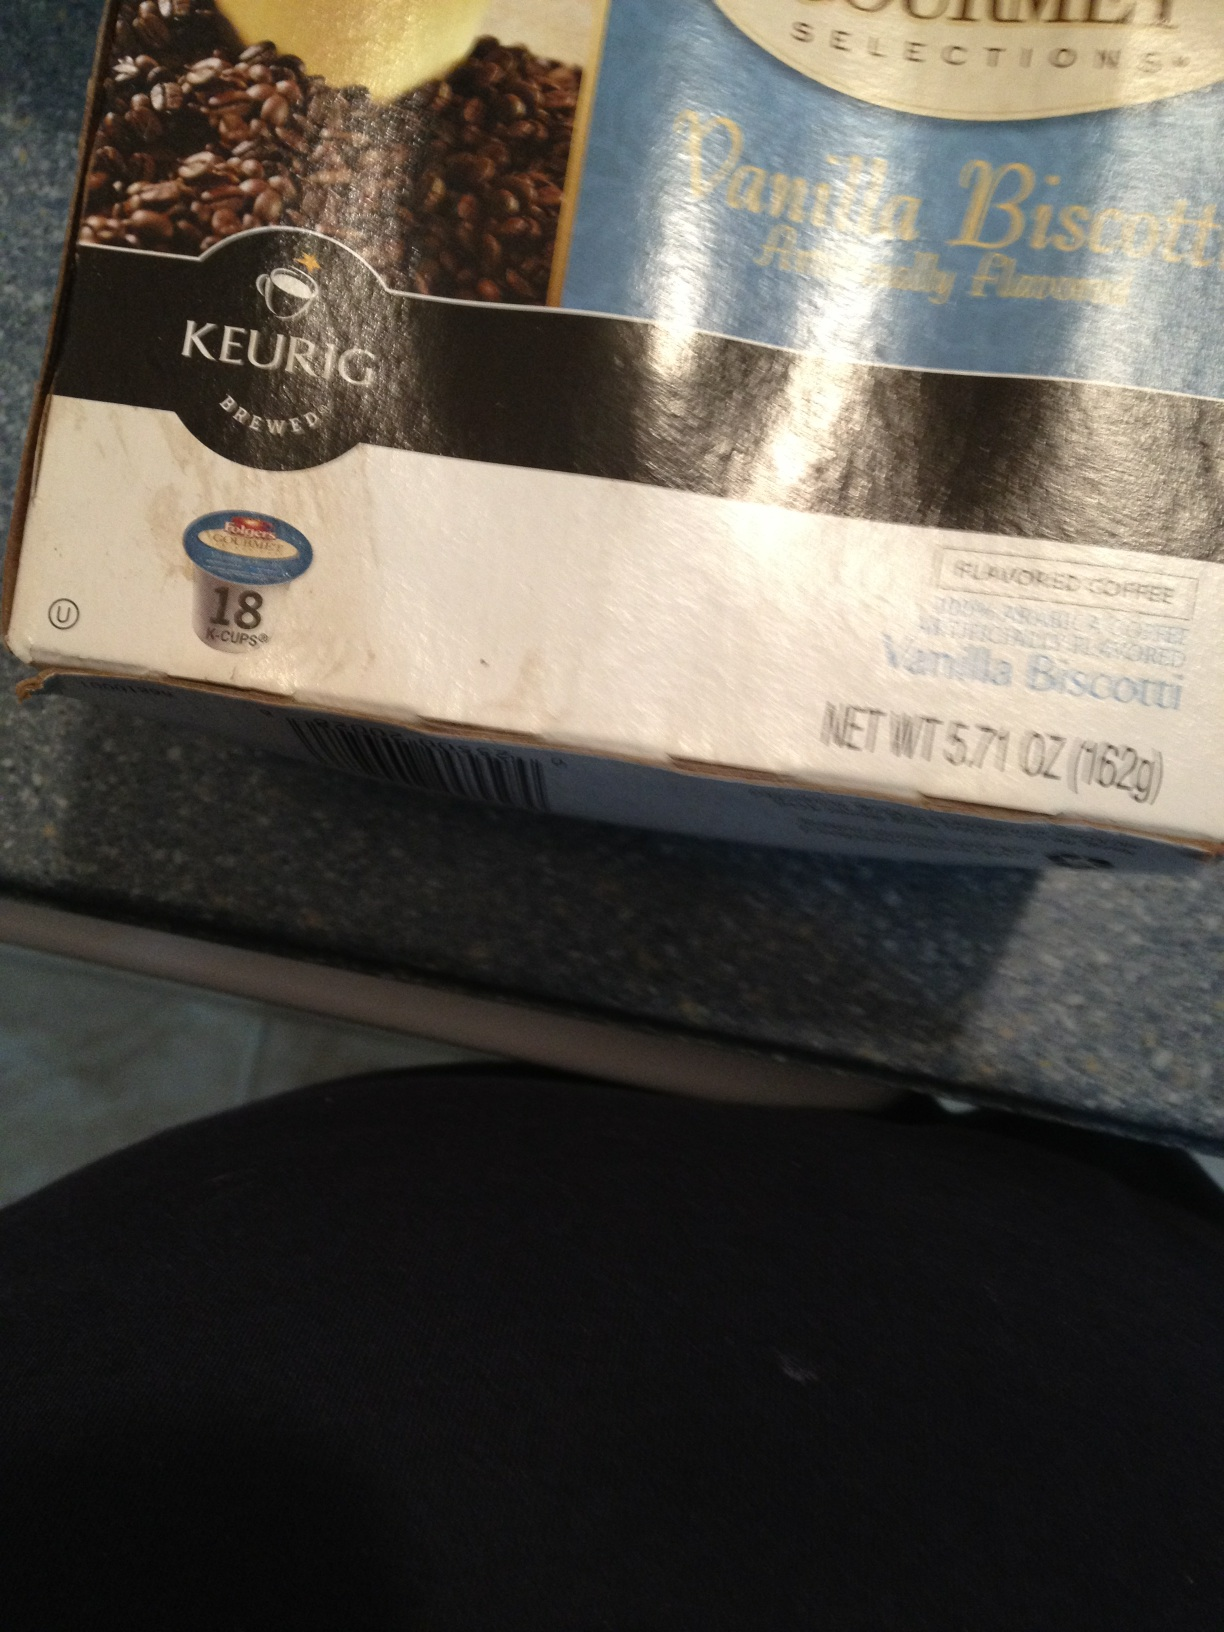What is the net weight of this product? The net weight of this product is 5.71 ounces, which is equivalent to 162 grams. 